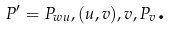Convert formula to latex. <formula><loc_0><loc_0><loc_500><loc_500>P ^ { \prime } = P _ { w u } , ( u , v ) , v , P _ { v } \text {.}</formula> 